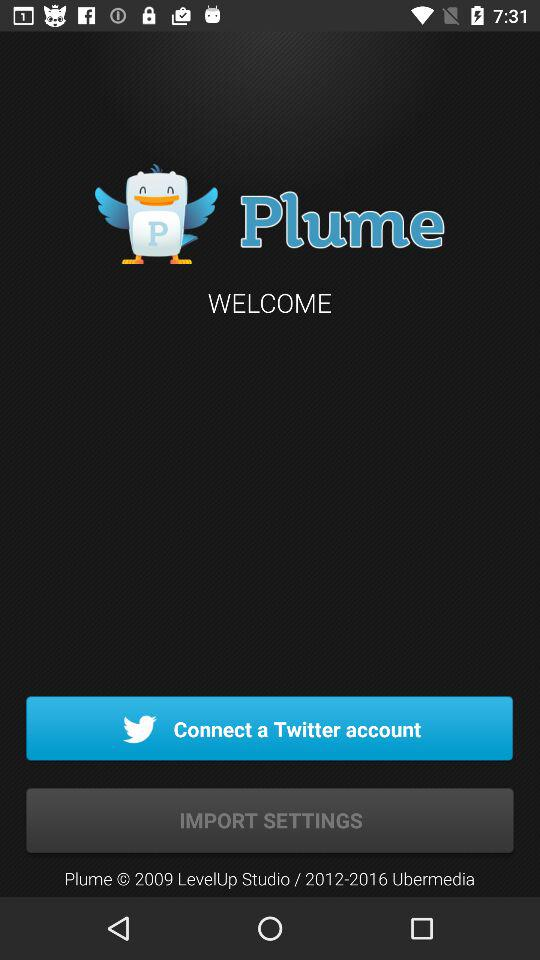Through what account can we connect? You can connect through "Twitter". 